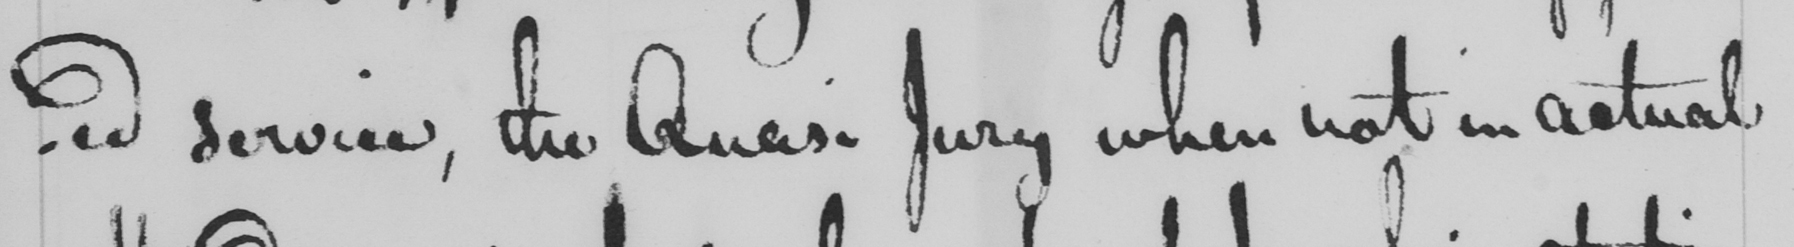Transcribe the text shown in this historical manuscript line. -ed service , the Quasi Jury when not in actual 